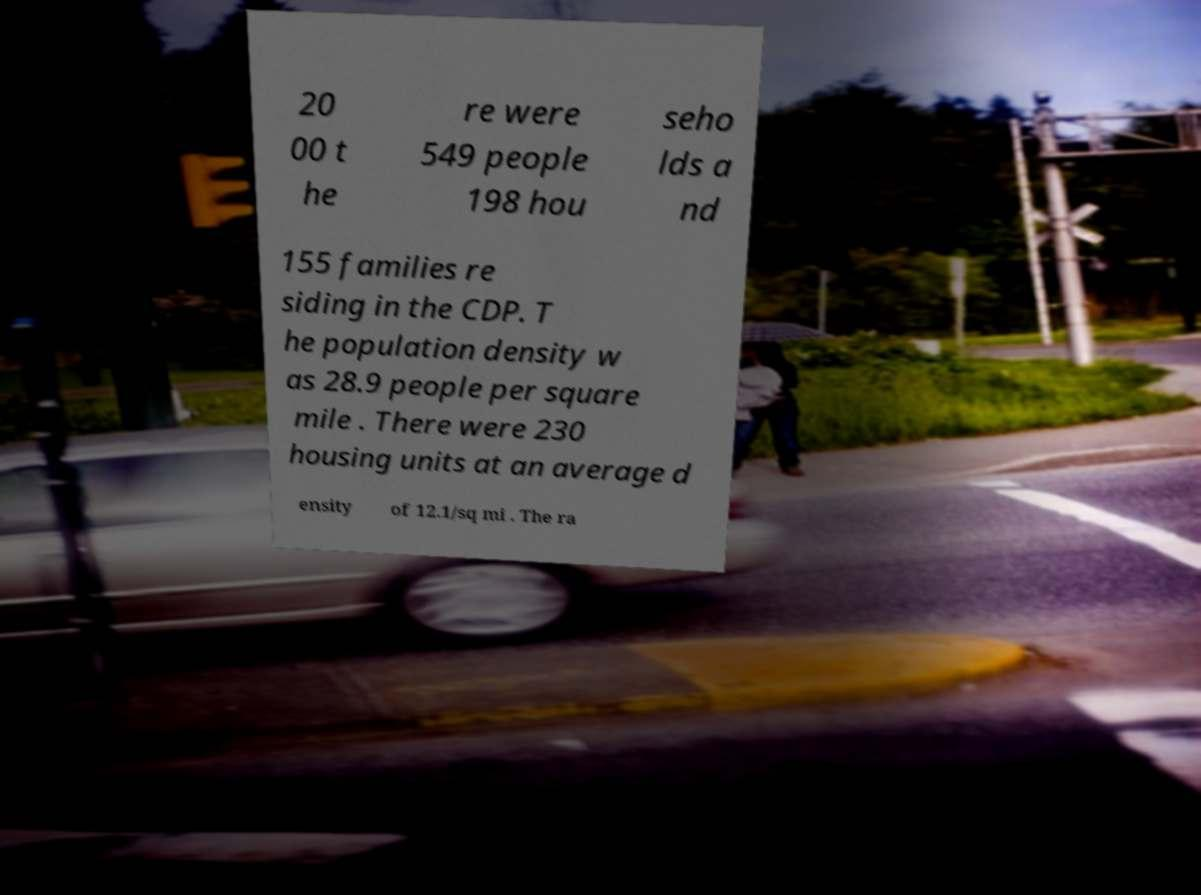Please read and relay the text visible in this image. What does it say? 20 00 t he re were 549 people 198 hou seho lds a nd 155 families re siding in the CDP. T he population density w as 28.9 people per square mile . There were 230 housing units at an average d ensity of 12.1/sq mi . The ra 